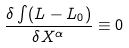<formula> <loc_0><loc_0><loc_500><loc_500>\frac { \delta \int ( L - L _ { 0 } ) } { \delta X ^ { \alpha } } \equiv 0</formula> 